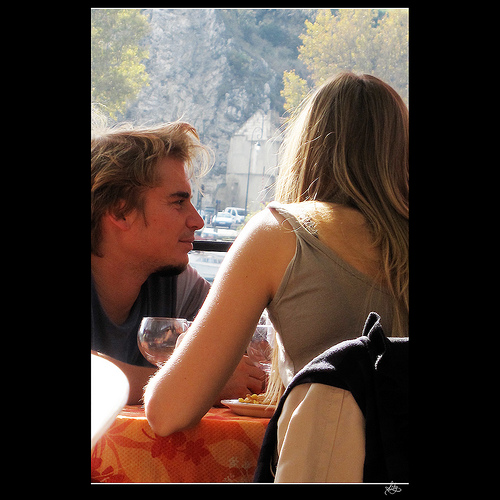<image>
Can you confirm if the jacket is on the woman? No. The jacket is not positioned on the woman. They may be near each other, but the jacket is not supported by or resting on top of the woman. 